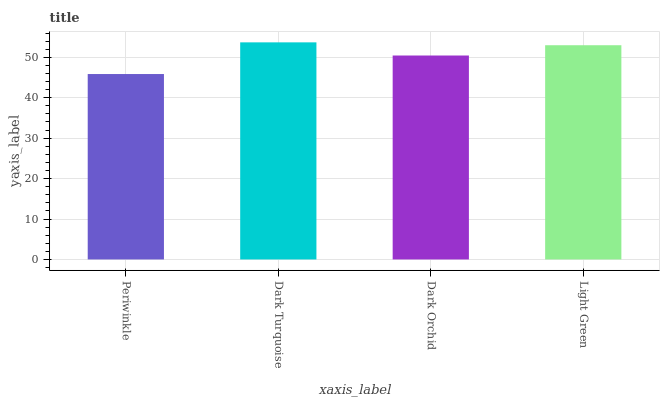Is Dark Orchid the minimum?
Answer yes or no. No. Is Dark Orchid the maximum?
Answer yes or no. No. Is Dark Turquoise greater than Dark Orchid?
Answer yes or no. Yes. Is Dark Orchid less than Dark Turquoise?
Answer yes or no. Yes. Is Dark Orchid greater than Dark Turquoise?
Answer yes or no. No. Is Dark Turquoise less than Dark Orchid?
Answer yes or no. No. Is Light Green the high median?
Answer yes or no. Yes. Is Dark Orchid the low median?
Answer yes or no. Yes. Is Dark Turquoise the high median?
Answer yes or no. No. Is Dark Turquoise the low median?
Answer yes or no. No. 